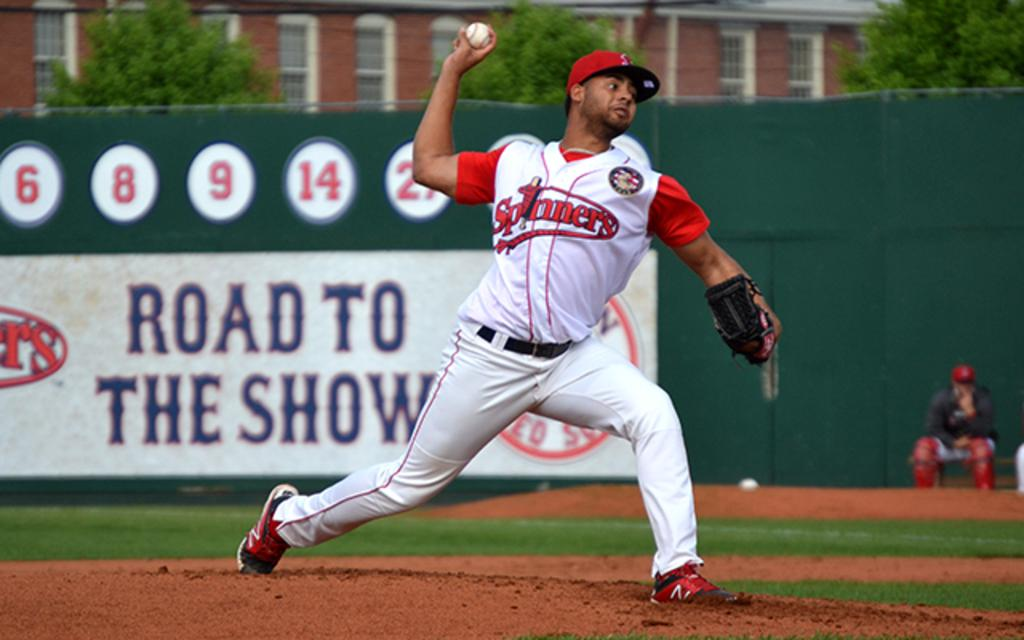<image>
Offer a succinct explanation of the picture presented. Baseball player wearing a jersey which says Spinners throwing a ball. 